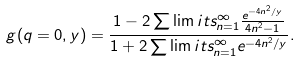Convert formula to latex. <formula><loc_0><loc_0><loc_500><loc_500>g ( q = 0 , y ) = \frac { 1 - 2 \sum \lim i t s _ { n = 1 } ^ { \infty } \frac { e ^ { - 4 n ^ { 2 } / y } } { 4 n ^ { 2 } - 1 } } { 1 + 2 \sum \lim i t s _ { n = 1 } ^ { \infty } e ^ { - 4 n ^ { 2 } / y } } .</formula> 